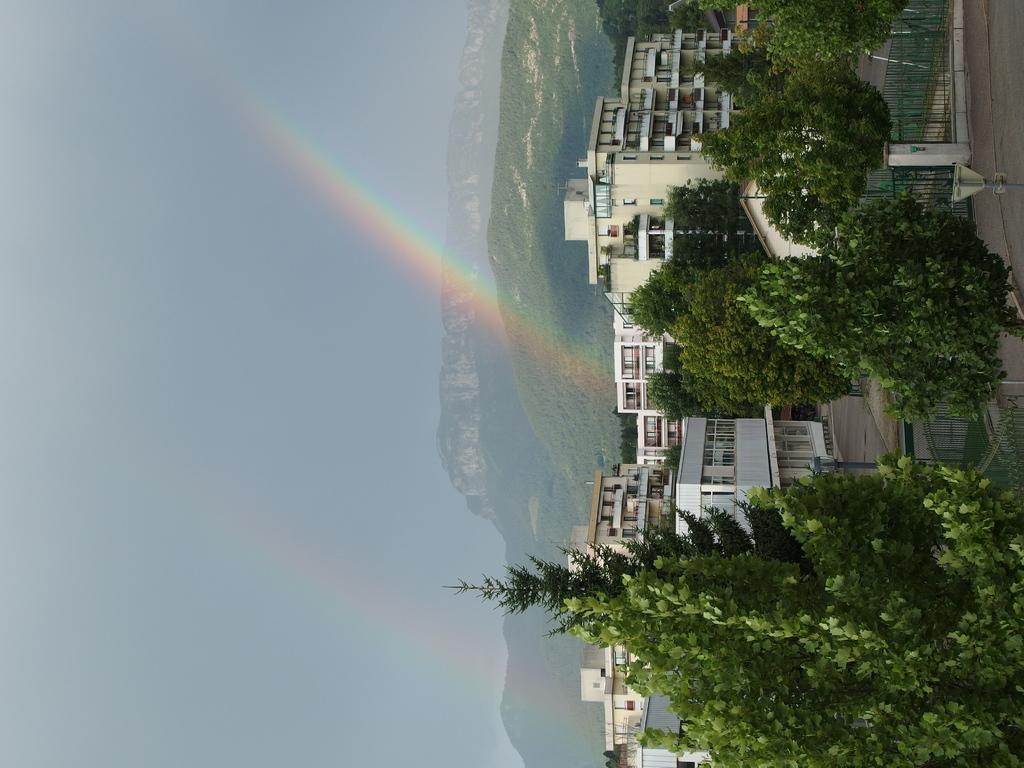Can you describe this image briefly? This picture is clicked outside. In the foreground we can see the trees, metal fence and the buildings and some other objects and we can see the poles. In the background we can see the sky, rainbow, hills and the green grass. 